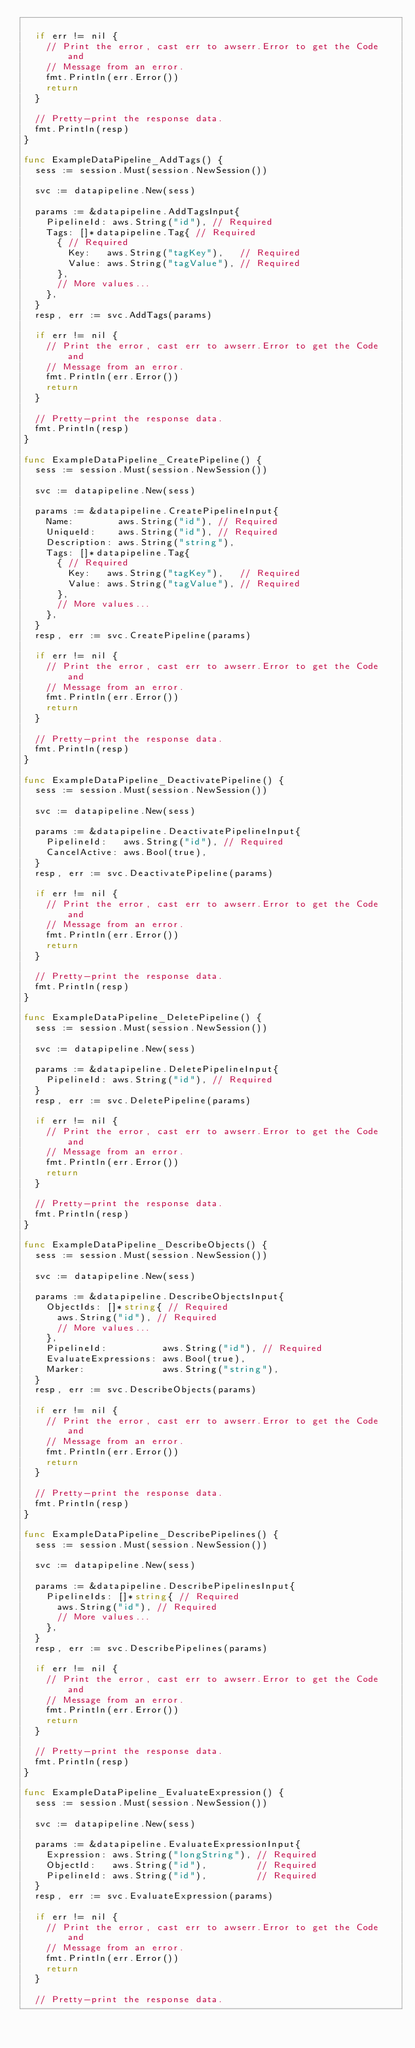Convert code to text. <code><loc_0><loc_0><loc_500><loc_500><_Go_>
	if err != nil {
		// Print the error, cast err to awserr.Error to get the Code and
		// Message from an error.
		fmt.Println(err.Error())
		return
	}

	// Pretty-print the response data.
	fmt.Println(resp)
}

func ExampleDataPipeline_AddTags() {
	sess := session.Must(session.NewSession())

	svc := datapipeline.New(sess)

	params := &datapipeline.AddTagsInput{
		PipelineId: aws.String("id"), // Required
		Tags: []*datapipeline.Tag{ // Required
			{ // Required
				Key:   aws.String("tagKey"),   // Required
				Value: aws.String("tagValue"), // Required
			},
			// More values...
		},
	}
	resp, err := svc.AddTags(params)

	if err != nil {
		// Print the error, cast err to awserr.Error to get the Code and
		// Message from an error.
		fmt.Println(err.Error())
		return
	}

	// Pretty-print the response data.
	fmt.Println(resp)
}

func ExampleDataPipeline_CreatePipeline() {
	sess := session.Must(session.NewSession())

	svc := datapipeline.New(sess)

	params := &datapipeline.CreatePipelineInput{
		Name:        aws.String("id"), // Required
		UniqueId:    aws.String("id"), // Required
		Description: aws.String("string"),
		Tags: []*datapipeline.Tag{
			{ // Required
				Key:   aws.String("tagKey"),   // Required
				Value: aws.String("tagValue"), // Required
			},
			// More values...
		},
	}
	resp, err := svc.CreatePipeline(params)

	if err != nil {
		// Print the error, cast err to awserr.Error to get the Code and
		// Message from an error.
		fmt.Println(err.Error())
		return
	}

	// Pretty-print the response data.
	fmt.Println(resp)
}

func ExampleDataPipeline_DeactivatePipeline() {
	sess := session.Must(session.NewSession())

	svc := datapipeline.New(sess)

	params := &datapipeline.DeactivatePipelineInput{
		PipelineId:   aws.String("id"), // Required
		CancelActive: aws.Bool(true),
	}
	resp, err := svc.DeactivatePipeline(params)

	if err != nil {
		// Print the error, cast err to awserr.Error to get the Code and
		// Message from an error.
		fmt.Println(err.Error())
		return
	}

	// Pretty-print the response data.
	fmt.Println(resp)
}

func ExampleDataPipeline_DeletePipeline() {
	sess := session.Must(session.NewSession())

	svc := datapipeline.New(sess)

	params := &datapipeline.DeletePipelineInput{
		PipelineId: aws.String("id"), // Required
	}
	resp, err := svc.DeletePipeline(params)

	if err != nil {
		// Print the error, cast err to awserr.Error to get the Code and
		// Message from an error.
		fmt.Println(err.Error())
		return
	}

	// Pretty-print the response data.
	fmt.Println(resp)
}

func ExampleDataPipeline_DescribeObjects() {
	sess := session.Must(session.NewSession())

	svc := datapipeline.New(sess)

	params := &datapipeline.DescribeObjectsInput{
		ObjectIds: []*string{ // Required
			aws.String("id"), // Required
			// More values...
		},
		PipelineId:          aws.String("id"), // Required
		EvaluateExpressions: aws.Bool(true),
		Marker:              aws.String("string"),
	}
	resp, err := svc.DescribeObjects(params)

	if err != nil {
		// Print the error, cast err to awserr.Error to get the Code and
		// Message from an error.
		fmt.Println(err.Error())
		return
	}

	// Pretty-print the response data.
	fmt.Println(resp)
}

func ExampleDataPipeline_DescribePipelines() {
	sess := session.Must(session.NewSession())

	svc := datapipeline.New(sess)

	params := &datapipeline.DescribePipelinesInput{
		PipelineIds: []*string{ // Required
			aws.String("id"), // Required
			// More values...
		},
	}
	resp, err := svc.DescribePipelines(params)

	if err != nil {
		// Print the error, cast err to awserr.Error to get the Code and
		// Message from an error.
		fmt.Println(err.Error())
		return
	}

	// Pretty-print the response data.
	fmt.Println(resp)
}

func ExampleDataPipeline_EvaluateExpression() {
	sess := session.Must(session.NewSession())

	svc := datapipeline.New(sess)

	params := &datapipeline.EvaluateExpressionInput{
		Expression: aws.String("longString"), // Required
		ObjectId:   aws.String("id"),         // Required
		PipelineId: aws.String("id"),         // Required
	}
	resp, err := svc.EvaluateExpression(params)

	if err != nil {
		// Print the error, cast err to awserr.Error to get the Code and
		// Message from an error.
		fmt.Println(err.Error())
		return
	}

	// Pretty-print the response data.</code> 